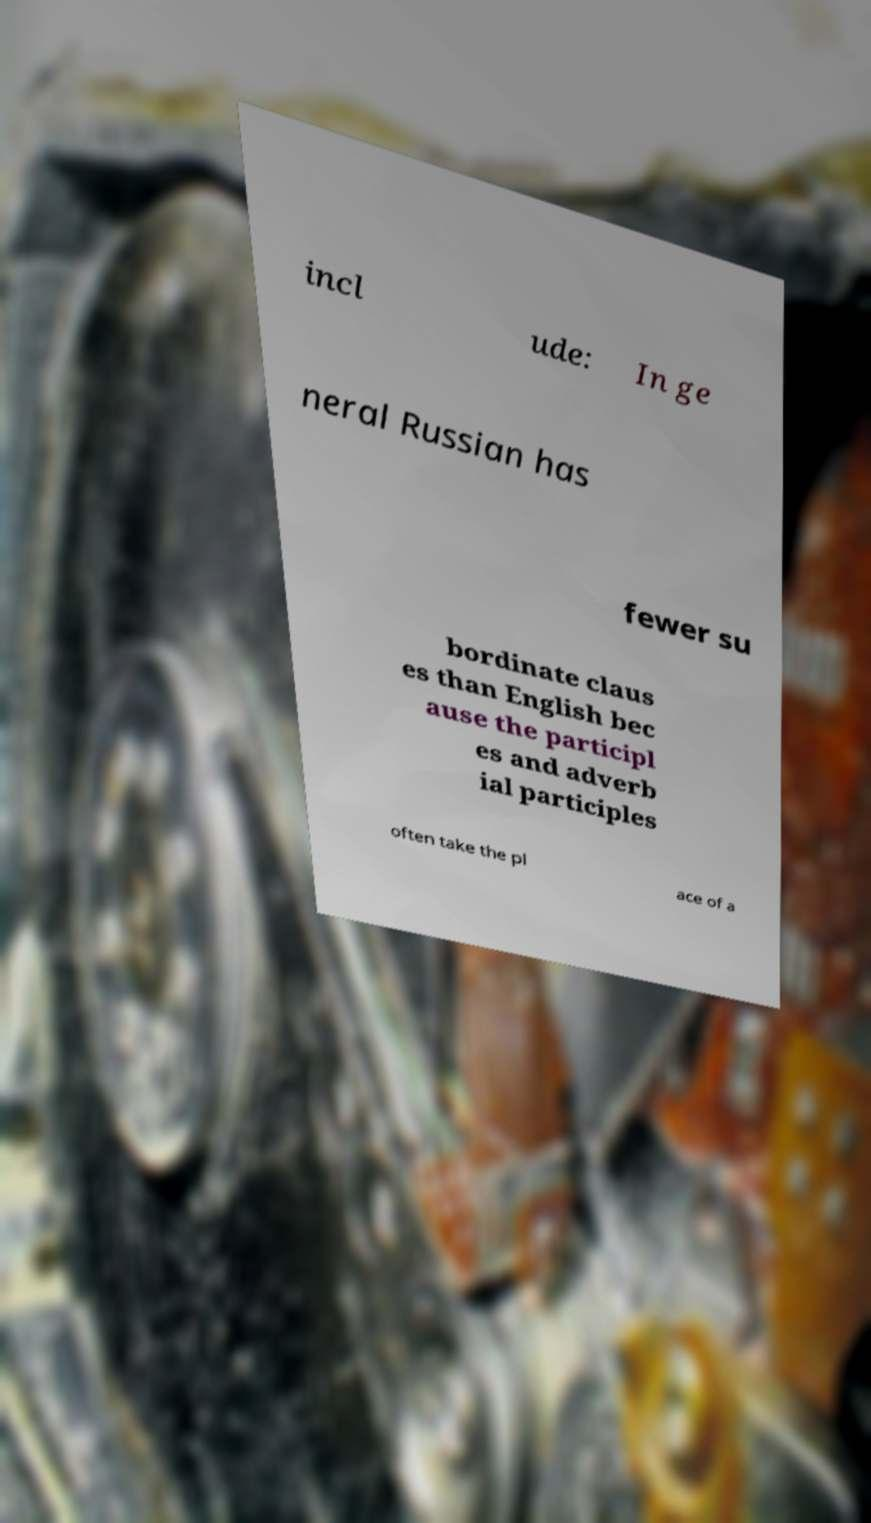I need the written content from this picture converted into text. Can you do that? incl ude: In ge neral Russian has fewer su bordinate claus es than English bec ause the participl es and adverb ial participles often take the pl ace of a 